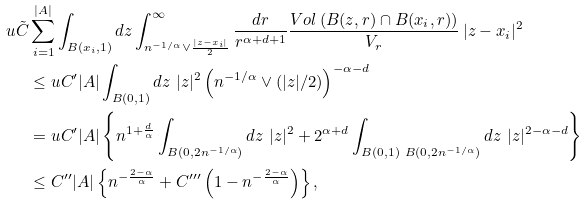<formula> <loc_0><loc_0><loc_500><loc_500>u \tilde { C } & \sum _ { i = 1 } ^ { | A | } \int _ { B ( x _ { i } , 1 ) } d z \int _ { n ^ { - 1 / \alpha } \vee \frac { | z - x _ { i } | } { 2 } } ^ { \infty } \frac { d r } { r ^ { \alpha + d + 1 } } \frac { V o l \left ( B ( z , r ) \cap B ( x _ { i } , r ) \right ) } { V _ { r } } \, | z - x _ { i } | ^ { 2 } \\ & \leq u C ^ { \prime } | A | \int _ { B ( 0 , 1 ) } d z \ | z | ^ { 2 } \left ( n ^ { - 1 / \alpha } \vee ( | z | / 2 ) \right ) ^ { - \alpha - d } \\ & = u C ^ { \prime } | A | \left \{ n ^ { 1 + \frac { d } { \alpha } } \int _ { B ( 0 , 2 n ^ { - 1 / \alpha } ) } d z \ | z | ^ { 2 } + 2 ^ { \alpha + d } \int _ { B ( 0 , 1 ) \ B ( 0 , 2 n ^ { - 1 / \alpha } ) } d z \ | z | ^ { 2 - \alpha - d } \right \} \\ & \leq C ^ { \prime \prime } | A | \left \{ n ^ { - \frac { 2 - \alpha } { \alpha } } + C ^ { \prime \prime \prime } \left ( 1 - n ^ { - \frac { 2 - \alpha } { \alpha } } \right ) \right \} ,</formula> 